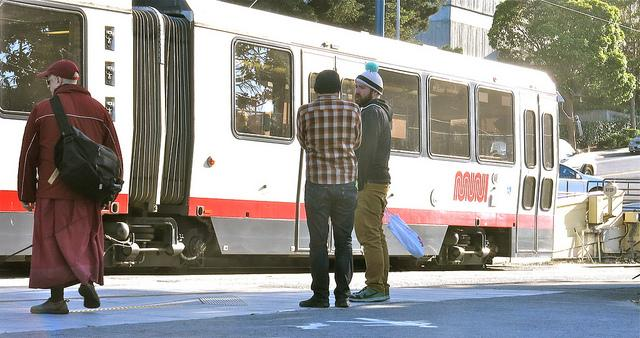What transmits electrical energy to the locomotive here?

Choices:
A) cell tower
B) gas tank
C) overhead line
D) furnace overhead line 